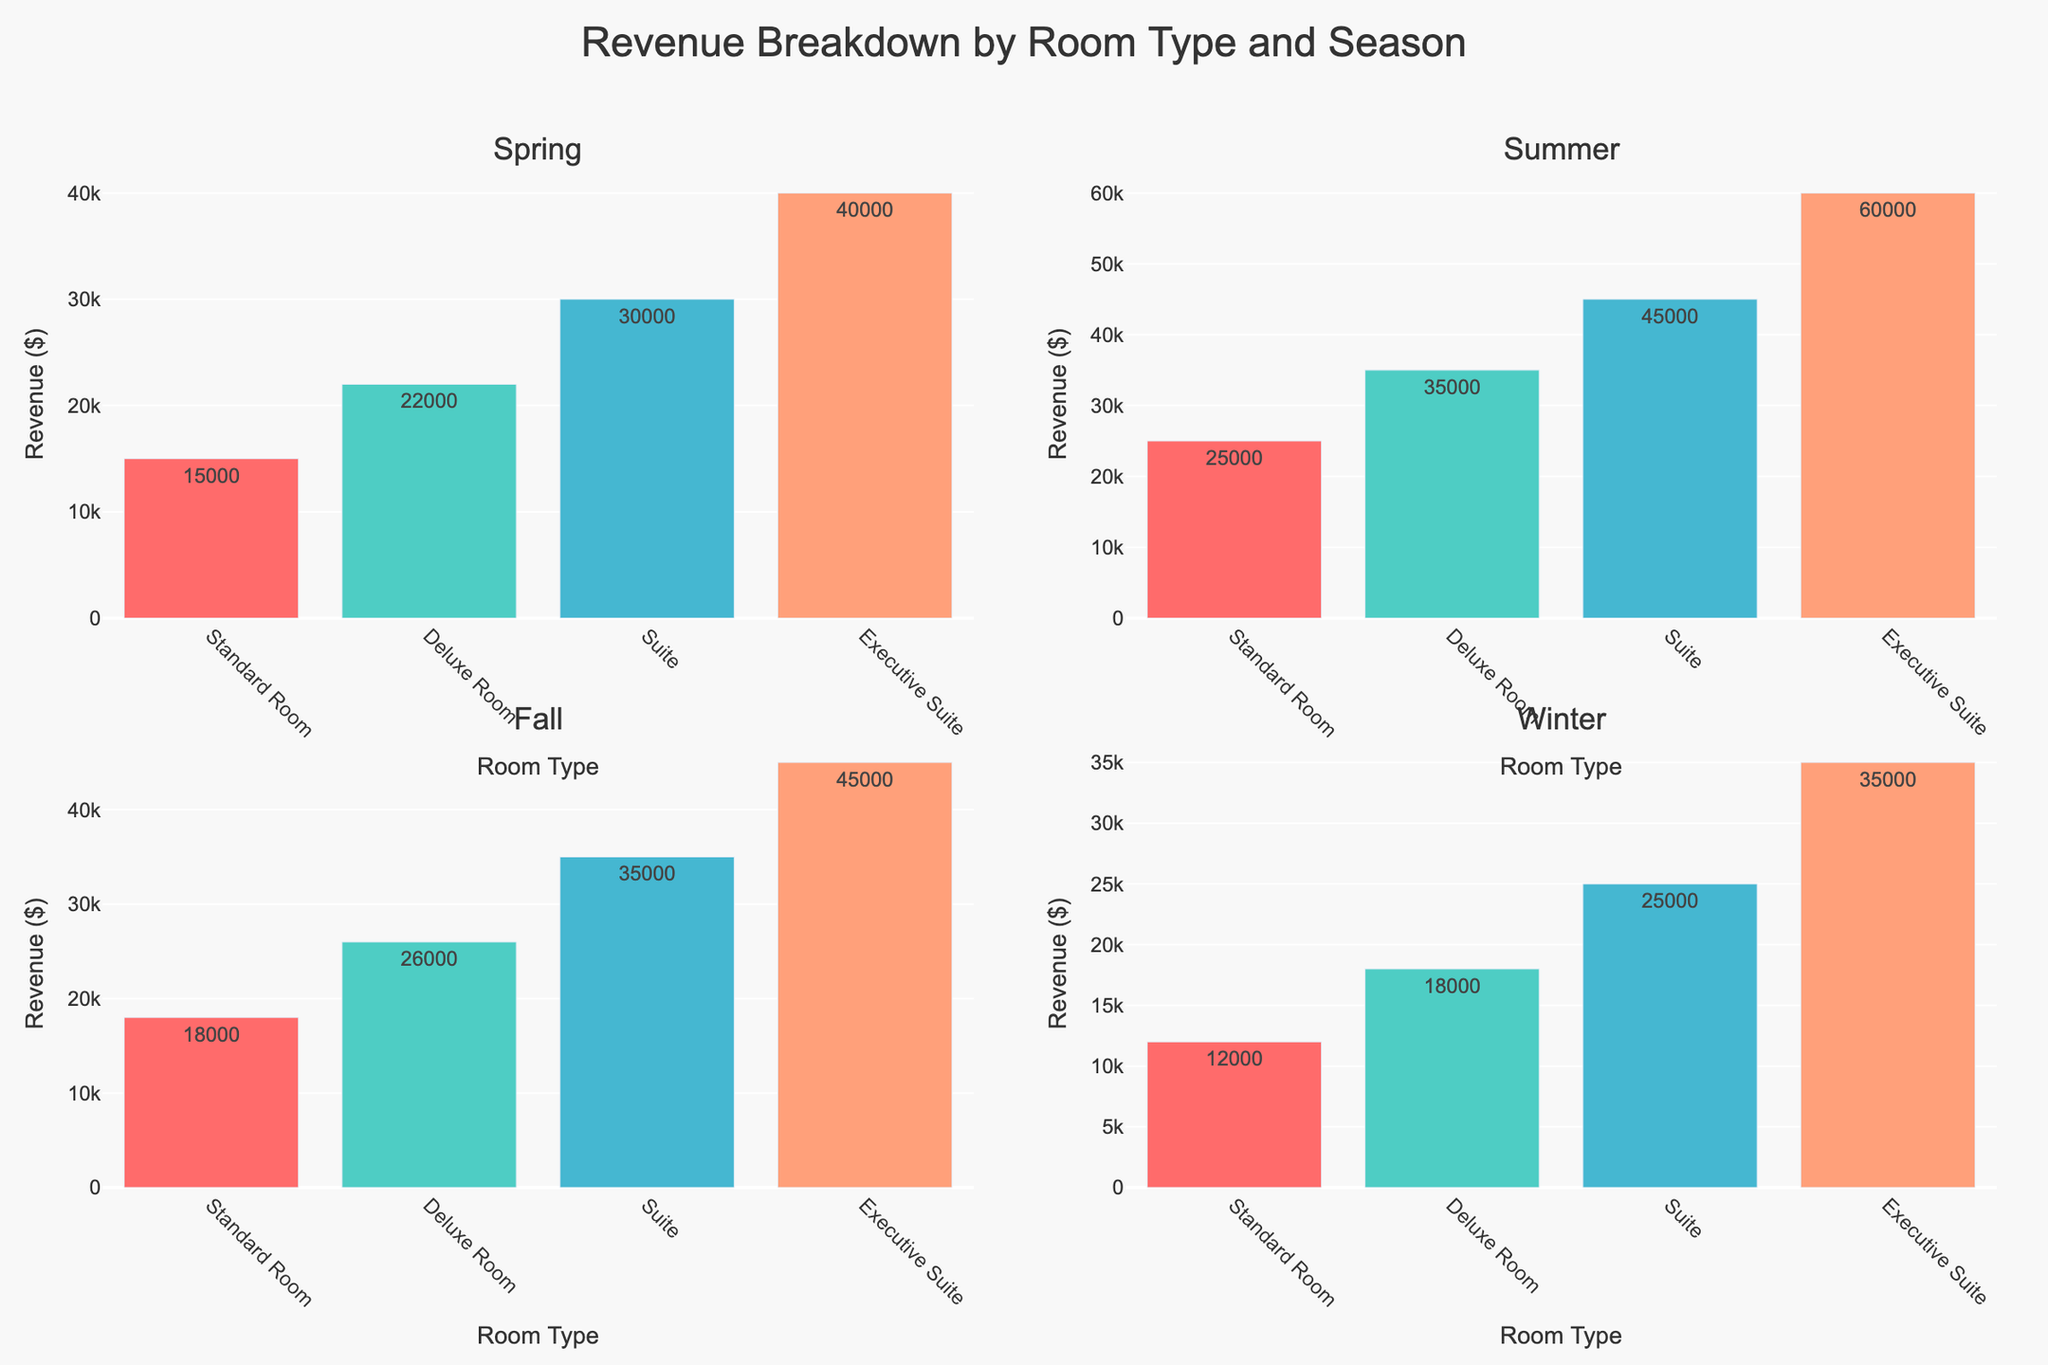what is the title of the figure? The title of the figure is displayed prominently at the top in the layout. By reading the title, you can identify the overall topic of the figure.
Answer: Programming Language Popularity and Repository Count what are the years compared in the subplot? There are two subplots, each representing the data for different years. The subplot titles indicate the years.
Answer: 2020 and 2022 which language has the highest popularity in 2022? The bubble chart for 2022 shows the popularity of each language on the x-axis. The language with the marker furthest to the right has the highest popularity.
Answer: Python which language increased its repository count the most from 2020 to 2022? Compare the bubble sizes for each language between the two years. The language with the largest increase in bubble size experienced the greatest growth in repository count.
Answer: Python among Python, JavaScript, and C++, which had the smallest increase in popularity from 2020 to 2022? To determine this, subtract the popularity in 2020 from the popularity in 2022 for each language and compare the values.
Answer: JavaScript what is the marker color of Python in 2022? Python's marker color can be identified by looking at the bubble chart for 2022 and recognizing the color used for Python.
Answer: Red which language saw the greatest increase in popularity from 2020 to 2022? Compare the increase in popularity for each language between the two years by subtracting the 2020 value from the 2022 value.
Answer: Rust how does popularity correlate with repository count for 2022? By observing the relative sizes of the bubbles and their positions, you can assess the correlation. Larger bubbles placed further to the right indicate a positive correlation.
Answer: Positive correlation based on the 2020 data, which language has a larger repository count, Rust or Go? Compare the bubble sizes of Rust and Go in the 2020 subplot. The larger bubble size corresponds to a higher repository count.
Answer: Go which languages have a greater than 90 popularity in any year shown? In the figure, check the x-axis values for the bubbles that go beyond 90 in either of the subplots.
Answer: Python 